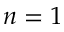Convert formula to latex. <formula><loc_0><loc_0><loc_500><loc_500>n = 1</formula> 